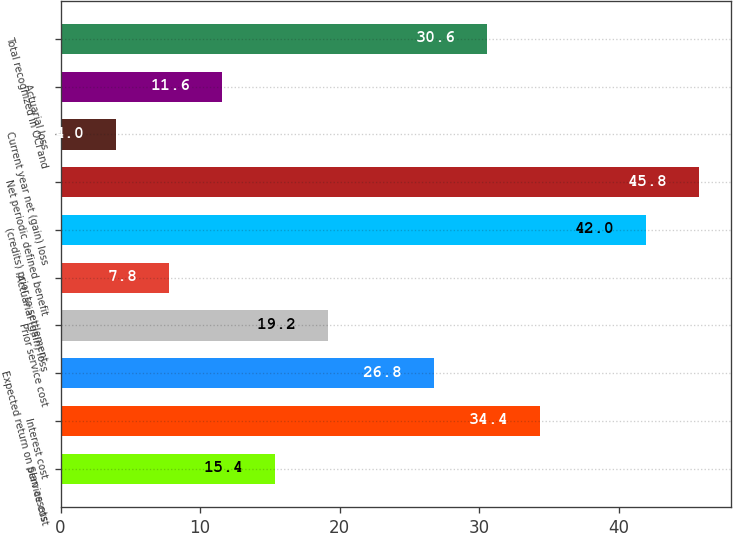<chart> <loc_0><loc_0><loc_500><loc_500><bar_chart><fcel>Service cost<fcel>Interest cost<fcel>Expected return on plan assets<fcel>Prior service cost<fcel>Actuarial (gain) loss<fcel>(credits) prior to settlement<fcel>Net periodic defined benefit<fcel>Current year net (gain) loss<fcel>Actuarial loss<fcel>Total recognized in OCI and<nl><fcel>15.4<fcel>34.4<fcel>26.8<fcel>19.2<fcel>7.8<fcel>42<fcel>45.8<fcel>4<fcel>11.6<fcel>30.6<nl></chart> 